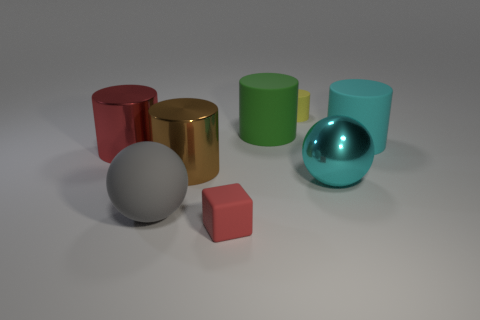Subtract all cyan cylinders. How many cylinders are left? 4 Subtract 3 cylinders. How many cylinders are left? 2 Subtract all red cylinders. How many cylinders are left? 4 Add 1 cyan balls. How many objects exist? 9 Subtract all brown cylinders. Subtract all red spheres. How many cylinders are left? 4 Subtract all cylinders. How many objects are left? 3 Subtract 0 gray blocks. How many objects are left? 8 Subtract all small green metal things. Subtract all large matte cylinders. How many objects are left? 6 Add 4 red metal cylinders. How many red metal cylinders are left? 5 Add 6 red metal cylinders. How many red metal cylinders exist? 7 